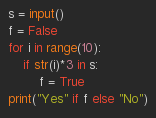<code> <loc_0><loc_0><loc_500><loc_500><_Python_>s = input()
f = False
for i in range(10):
    if str(i)*3 in s:
        f = True
print("Yes" if f else "No")</code> 